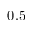Convert formula to latex. <formula><loc_0><loc_0><loc_500><loc_500>0 . 5</formula> 